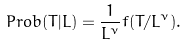<formula> <loc_0><loc_0><loc_500><loc_500>P r o b ( T | L ) = \frac { 1 } { L ^ { \nu } } f ( T / L ^ { \nu } ) .</formula> 